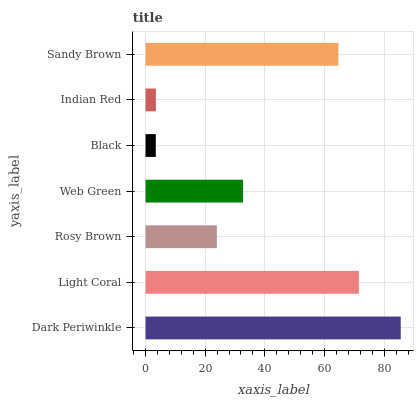Is Black the minimum?
Answer yes or no. Yes. Is Dark Periwinkle the maximum?
Answer yes or no. Yes. Is Light Coral the minimum?
Answer yes or no. No. Is Light Coral the maximum?
Answer yes or no. No. Is Dark Periwinkle greater than Light Coral?
Answer yes or no. Yes. Is Light Coral less than Dark Periwinkle?
Answer yes or no. Yes. Is Light Coral greater than Dark Periwinkle?
Answer yes or no. No. Is Dark Periwinkle less than Light Coral?
Answer yes or no. No. Is Web Green the high median?
Answer yes or no. Yes. Is Web Green the low median?
Answer yes or no. Yes. Is Indian Red the high median?
Answer yes or no. No. Is Black the low median?
Answer yes or no. No. 